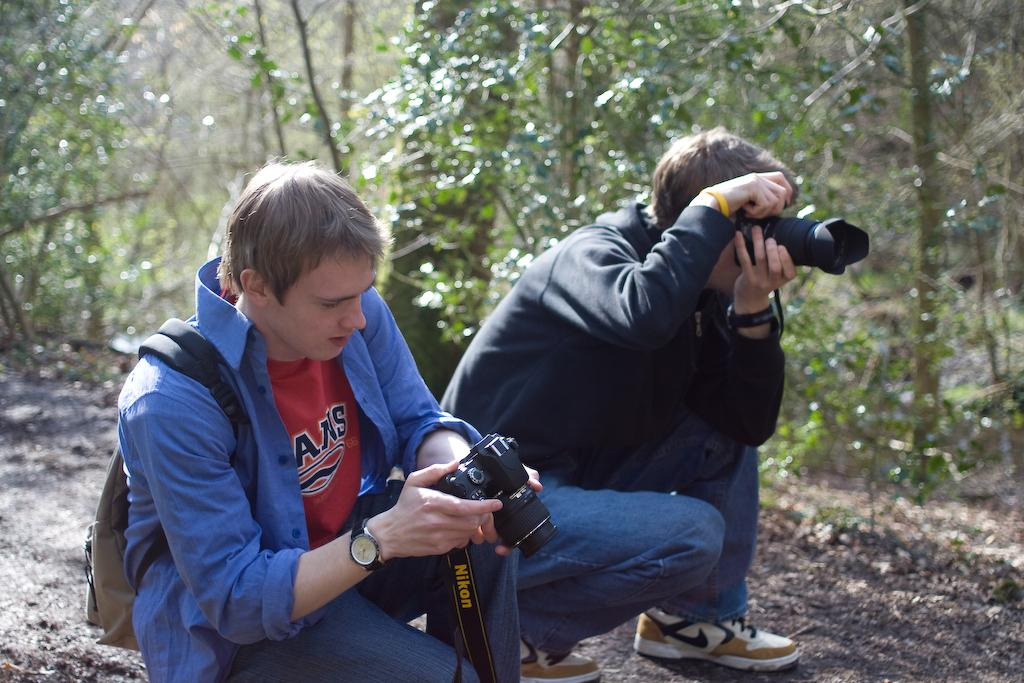How many people are in the image? There are two people in the image. What are the people doing in the image? The people are sitting on the land. What objects are the people holding in the image? The people are holding cameras. What type of vegetation can be seen in the image? There are many trees in the image. What type of pie is being served to the people in the image? There is no pie present in the image; the people are holding cameras. Is there a crook in the image trying to steal the cameras from the people? There is no crook present in the image; the people are simply holding cameras. 